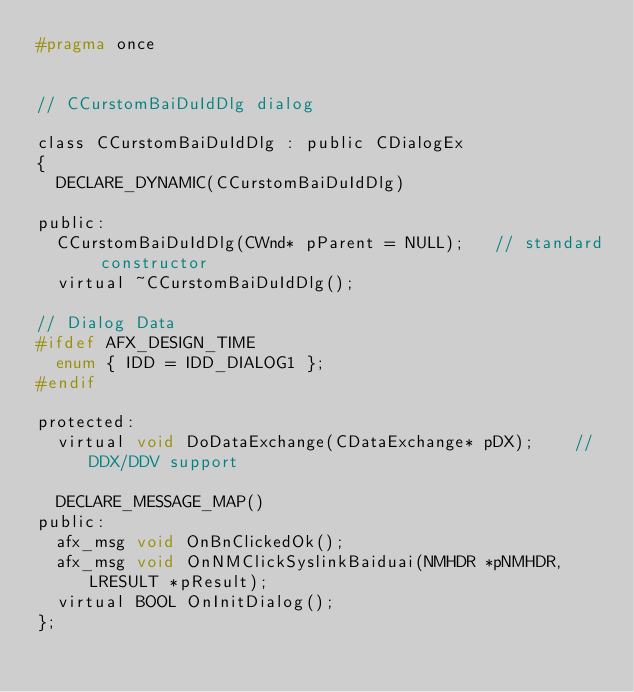Convert code to text. <code><loc_0><loc_0><loc_500><loc_500><_C_>#pragma once


// CCurstomBaiDuIdDlg dialog

class CCurstomBaiDuIdDlg : public CDialogEx
{
	DECLARE_DYNAMIC(CCurstomBaiDuIdDlg)

public:
	CCurstomBaiDuIdDlg(CWnd* pParent = NULL);   // standard constructor
	virtual ~CCurstomBaiDuIdDlg();

// Dialog Data
#ifdef AFX_DESIGN_TIME
	enum { IDD = IDD_DIALOG1 };
#endif

protected:
	virtual void DoDataExchange(CDataExchange* pDX);    // DDX/DDV support

	DECLARE_MESSAGE_MAP()
public:
	afx_msg void OnBnClickedOk();
	afx_msg void OnNMClickSyslinkBaiduai(NMHDR *pNMHDR, LRESULT *pResult);
	virtual BOOL OnInitDialog();
};
</code> 